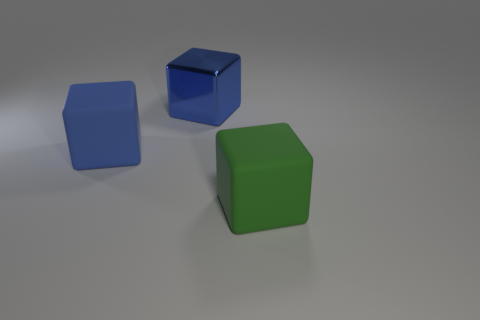What does the arrangement of the cubes tell us about the depth of the scene? The arrangement of the cubes creates an impression of depth. The green cube is closest to us, while the blue and the third cube's positions suggest they are further away. The shadows and perspective lines, though subtle, contribute to the sense of three-dimensional space in the image. 